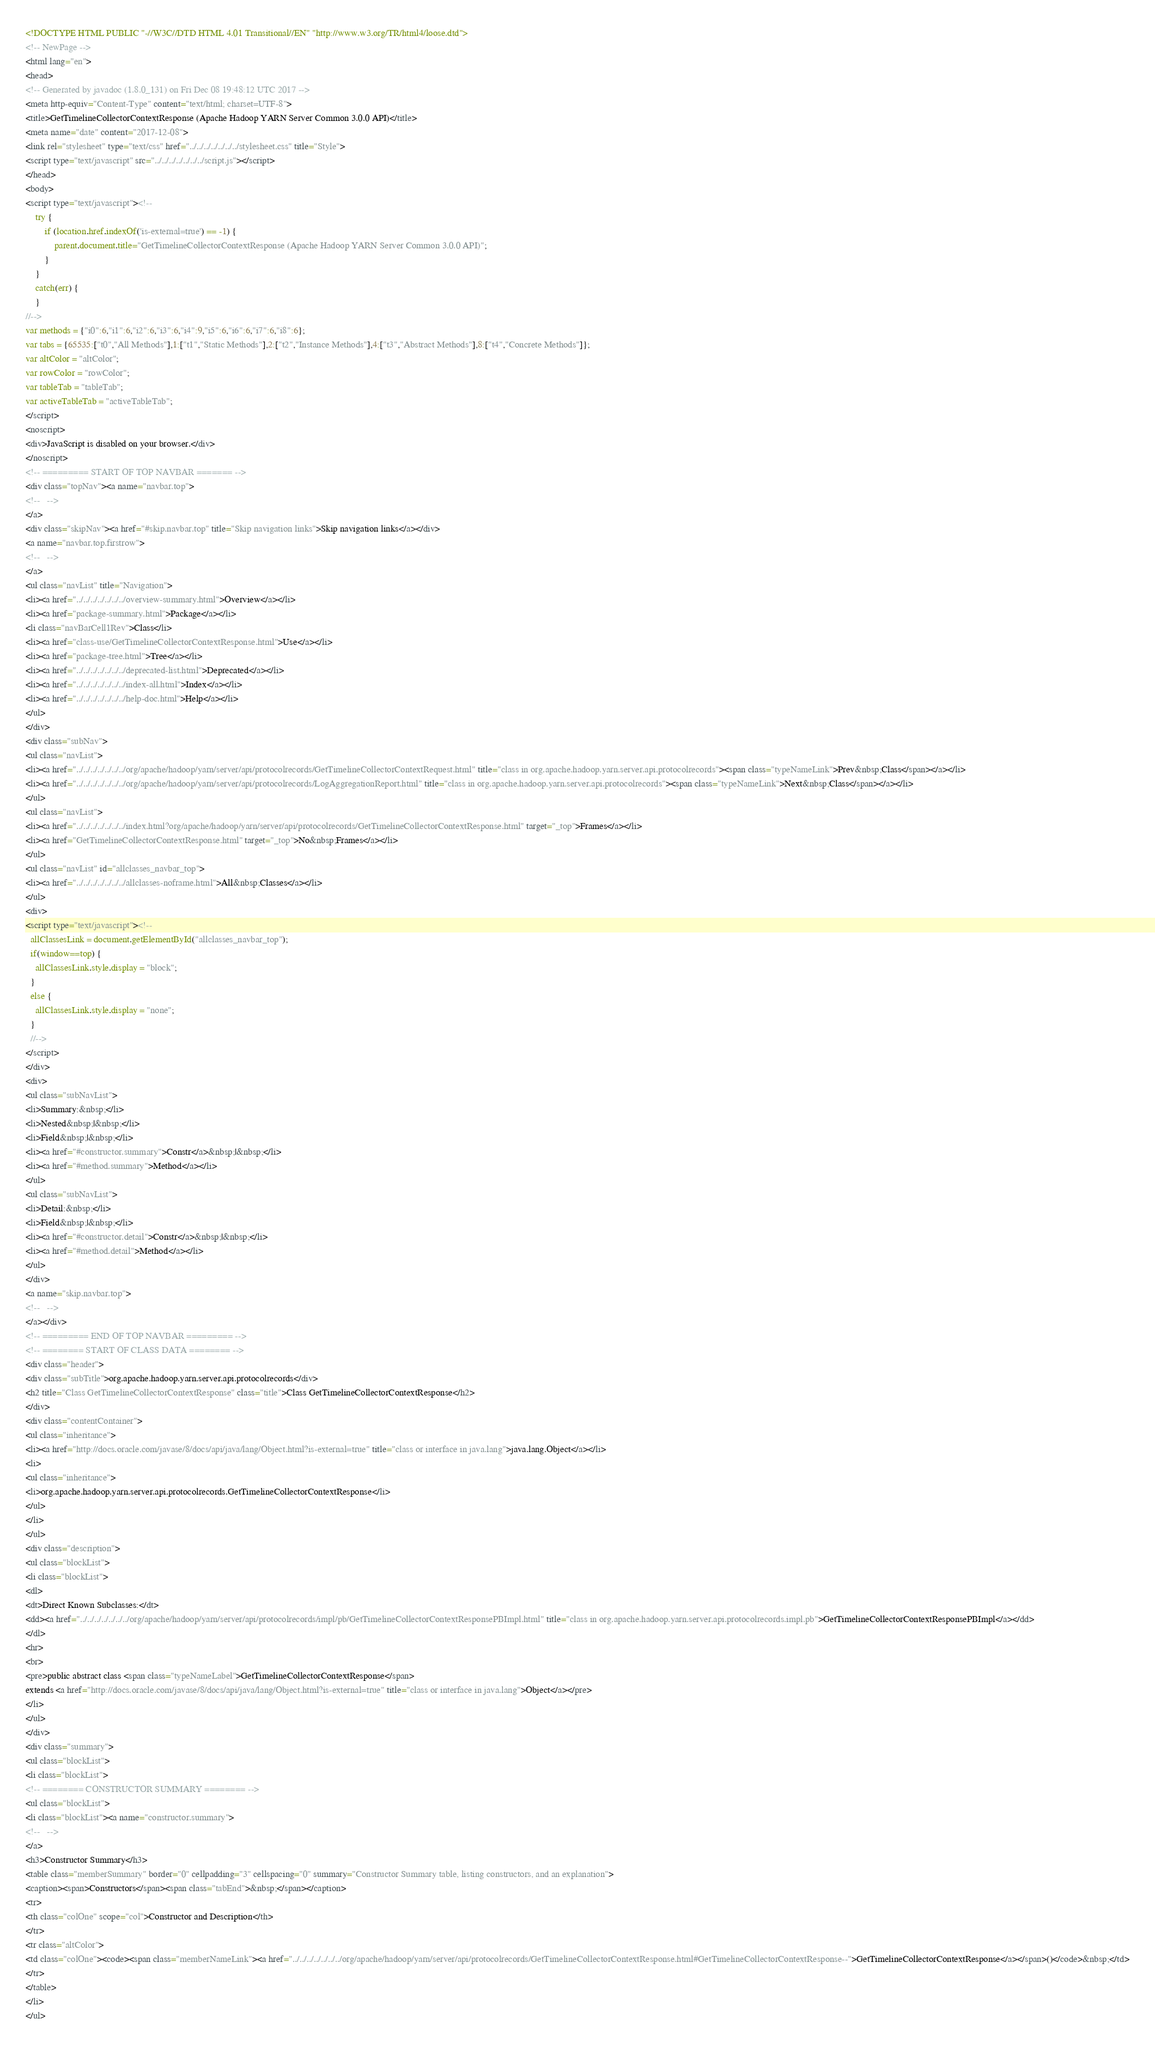<code> <loc_0><loc_0><loc_500><loc_500><_HTML_><!DOCTYPE HTML PUBLIC "-//W3C//DTD HTML 4.01 Transitional//EN" "http://www.w3.org/TR/html4/loose.dtd">
<!-- NewPage -->
<html lang="en">
<head>
<!-- Generated by javadoc (1.8.0_131) on Fri Dec 08 19:48:12 UTC 2017 -->
<meta http-equiv="Content-Type" content="text/html; charset=UTF-8">
<title>GetTimelineCollectorContextResponse (Apache Hadoop YARN Server Common 3.0.0 API)</title>
<meta name="date" content="2017-12-08">
<link rel="stylesheet" type="text/css" href="../../../../../../../stylesheet.css" title="Style">
<script type="text/javascript" src="../../../../../../../script.js"></script>
</head>
<body>
<script type="text/javascript"><!--
    try {
        if (location.href.indexOf('is-external=true') == -1) {
            parent.document.title="GetTimelineCollectorContextResponse (Apache Hadoop YARN Server Common 3.0.0 API)";
        }
    }
    catch(err) {
    }
//-->
var methods = {"i0":6,"i1":6,"i2":6,"i3":6,"i4":9,"i5":6,"i6":6,"i7":6,"i8":6};
var tabs = {65535:["t0","All Methods"],1:["t1","Static Methods"],2:["t2","Instance Methods"],4:["t3","Abstract Methods"],8:["t4","Concrete Methods"]};
var altColor = "altColor";
var rowColor = "rowColor";
var tableTab = "tableTab";
var activeTableTab = "activeTableTab";
</script>
<noscript>
<div>JavaScript is disabled on your browser.</div>
</noscript>
<!-- ========= START OF TOP NAVBAR ======= -->
<div class="topNav"><a name="navbar.top">
<!--   -->
</a>
<div class="skipNav"><a href="#skip.navbar.top" title="Skip navigation links">Skip navigation links</a></div>
<a name="navbar.top.firstrow">
<!--   -->
</a>
<ul class="navList" title="Navigation">
<li><a href="../../../../../../../overview-summary.html">Overview</a></li>
<li><a href="package-summary.html">Package</a></li>
<li class="navBarCell1Rev">Class</li>
<li><a href="class-use/GetTimelineCollectorContextResponse.html">Use</a></li>
<li><a href="package-tree.html">Tree</a></li>
<li><a href="../../../../../../../deprecated-list.html">Deprecated</a></li>
<li><a href="../../../../../../../index-all.html">Index</a></li>
<li><a href="../../../../../../../help-doc.html">Help</a></li>
</ul>
</div>
<div class="subNav">
<ul class="navList">
<li><a href="../../../../../../../org/apache/hadoop/yarn/server/api/protocolrecords/GetTimelineCollectorContextRequest.html" title="class in org.apache.hadoop.yarn.server.api.protocolrecords"><span class="typeNameLink">Prev&nbsp;Class</span></a></li>
<li><a href="../../../../../../../org/apache/hadoop/yarn/server/api/protocolrecords/LogAggregationReport.html" title="class in org.apache.hadoop.yarn.server.api.protocolrecords"><span class="typeNameLink">Next&nbsp;Class</span></a></li>
</ul>
<ul class="navList">
<li><a href="../../../../../../../index.html?org/apache/hadoop/yarn/server/api/protocolrecords/GetTimelineCollectorContextResponse.html" target="_top">Frames</a></li>
<li><a href="GetTimelineCollectorContextResponse.html" target="_top">No&nbsp;Frames</a></li>
</ul>
<ul class="navList" id="allclasses_navbar_top">
<li><a href="../../../../../../../allclasses-noframe.html">All&nbsp;Classes</a></li>
</ul>
<div>
<script type="text/javascript"><!--
  allClassesLink = document.getElementById("allclasses_navbar_top");
  if(window==top) {
    allClassesLink.style.display = "block";
  }
  else {
    allClassesLink.style.display = "none";
  }
  //-->
</script>
</div>
<div>
<ul class="subNavList">
<li>Summary:&nbsp;</li>
<li>Nested&nbsp;|&nbsp;</li>
<li>Field&nbsp;|&nbsp;</li>
<li><a href="#constructor.summary">Constr</a>&nbsp;|&nbsp;</li>
<li><a href="#method.summary">Method</a></li>
</ul>
<ul class="subNavList">
<li>Detail:&nbsp;</li>
<li>Field&nbsp;|&nbsp;</li>
<li><a href="#constructor.detail">Constr</a>&nbsp;|&nbsp;</li>
<li><a href="#method.detail">Method</a></li>
</ul>
</div>
<a name="skip.navbar.top">
<!--   -->
</a></div>
<!-- ========= END OF TOP NAVBAR ========= -->
<!-- ======== START OF CLASS DATA ======== -->
<div class="header">
<div class="subTitle">org.apache.hadoop.yarn.server.api.protocolrecords</div>
<h2 title="Class GetTimelineCollectorContextResponse" class="title">Class GetTimelineCollectorContextResponse</h2>
</div>
<div class="contentContainer">
<ul class="inheritance">
<li><a href="http://docs.oracle.com/javase/8/docs/api/java/lang/Object.html?is-external=true" title="class or interface in java.lang">java.lang.Object</a></li>
<li>
<ul class="inheritance">
<li>org.apache.hadoop.yarn.server.api.protocolrecords.GetTimelineCollectorContextResponse</li>
</ul>
</li>
</ul>
<div class="description">
<ul class="blockList">
<li class="blockList">
<dl>
<dt>Direct Known Subclasses:</dt>
<dd><a href="../../../../../../../org/apache/hadoop/yarn/server/api/protocolrecords/impl/pb/GetTimelineCollectorContextResponsePBImpl.html" title="class in org.apache.hadoop.yarn.server.api.protocolrecords.impl.pb">GetTimelineCollectorContextResponsePBImpl</a></dd>
</dl>
<hr>
<br>
<pre>public abstract class <span class="typeNameLabel">GetTimelineCollectorContextResponse</span>
extends <a href="http://docs.oracle.com/javase/8/docs/api/java/lang/Object.html?is-external=true" title="class or interface in java.lang">Object</a></pre>
</li>
</ul>
</div>
<div class="summary">
<ul class="blockList">
<li class="blockList">
<!-- ======== CONSTRUCTOR SUMMARY ======== -->
<ul class="blockList">
<li class="blockList"><a name="constructor.summary">
<!--   -->
</a>
<h3>Constructor Summary</h3>
<table class="memberSummary" border="0" cellpadding="3" cellspacing="0" summary="Constructor Summary table, listing constructors, and an explanation">
<caption><span>Constructors</span><span class="tabEnd">&nbsp;</span></caption>
<tr>
<th class="colOne" scope="col">Constructor and Description</th>
</tr>
<tr class="altColor">
<td class="colOne"><code><span class="memberNameLink"><a href="../../../../../../../org/apache/hadoop/yarn/server/api/protocolrecords/GetTimelineCollectorContextResponse.html#GetTimelineCollectorContextResponse--">GetTimelineCollectorContextResponse</a></span>()</code>&nbsp;</td>
</tr>
</table>
</li>
</ul></code> 